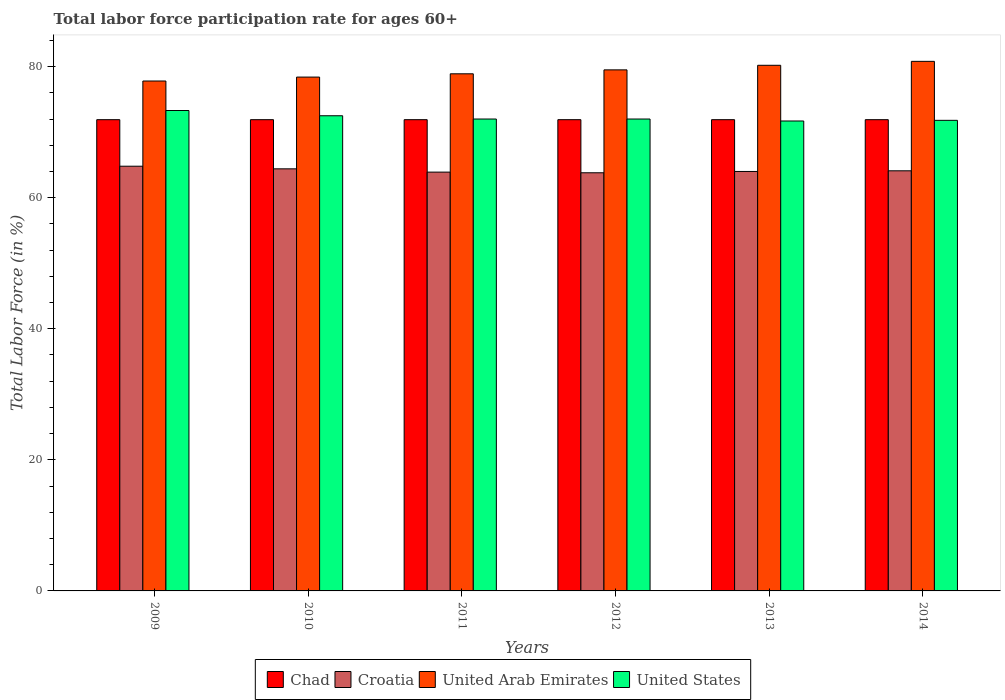How many groups of bars are there?
Your answer should be compact. 6. What is the label of the 6th group of bars from the left?
Provide a succinct answer. 2014. In how many cases, is the number of bars for a given year not equal to the number of legend labels?
Keep it short and to the point. 0. Across all years, what is the maximum labor force participation rate in United Arab Emirates?
Your answer should be compact. 80.8. Across all years, what is the minimum labor force participation rate in United Arab Emirates?
Make the answer very short. 77.8. In which year was the labor force participation rate in United Arab Emirates minimum?
Offer a terse response. 2009. What is the total labor force participation rate in United Arab Emirates in the graph?
Make the answer very short. 475.6. What is the difference between the labor force participation rate in Croatia in 2012 and that in 2013?
Give a very brief answer. -0.2. What is the difference between the labor force participation rate in United States in 2009 and the labor force participation rate in United Arab Emirates in 2013?
Your answer should be very brief. -6.9. What is the average labor force participation rate in Chad per year?
Keep it short and to the point. 71.9. In the year 2011, what is the difference between the labor force participation rate in United Arab Emirates and labor force participation rate in United States?
Give a very brief answer. 6.9. In how many years, is the labor force participation rate in Croatia greater than 8 %?
Your response must be concise. 6. What is the ratio of the labor force participation rate in Chad in 2010 to that in 2012?
Your answer should be compact. 1. Is the difference between the labor force participation rate in United Arab Emirates in 2009 and 2014 greater than the difference between the labor force participation rate in United States in 2009 and 2014?
Ensure brevity in your answer.  No. What is the difference between the highest and the second highest labor force participation rate in United States?
Offer a terse response. 0.8. What is the difference between the highest and the lowest labor force participation rate in Croatia?
Your answer should be compact. 1. In how many years, is the labor force participation rate in United States greater than the average labor force participation rate in United States taken over all years?
Your response must be concise. 2. Is the sum of the labor force participation rate in Chad in 2010 and 2011 greater than the maximum labor force participation rate in United States across all years?
Keep it short and to the point. Yes. Is it the case that in every year, the sum of the labor force participation rate in Chad and labor force participation rate in United States is greater than the sum of labor force participation rate in United Arab Emirates and labor force participation rate in Croatia?
Provide a short and direct response. No. What does the 4th bar from the left in 2014 represents?
Your response must be concise. United States. What does the 3rd bar from the right in 2014 represents?
Offer a terse response. Croatia. How many bars are there?
Your response must be concise. 24. Are all the bars in the graph horizontal?
Provide a succinct answer. No. How many years are there in the graph?
Provide a short and direct response. 6. What is the difference between two consecutive major ticks on the Y-axis?
Give a very brief answer. 20. Does the graph contain grids?
Your answer should be compact. No. How are the legend labels stacked?
Offer a very short reply. Horizontal. What is the title of the graph?
Keep it short and to the point. Total labor force participation rate for ages 60+. Does "Papua New Guinea" appear as one of the legend labels in the graph?
Offer a very short reply. No. What is the Total Labor Force (in %) of Chad in 2009?
Make the answer very short. 71.9. What is the Total Labor Force (in %) in Croatia in 2009?
Provide a short and direct response. 64.8. What is the Total Labor Force (in %) of United Arab Emirates in 2009?
Keep it short and to the point. 77.8. What is the Total Labor Force (in %) of United States in 2009?
Your answer should be compact. 73.3. What is the Total Labor Force (in %) of Chad in 2010?
Give a very brief answer. 71.9. What is the Total Labor Force (in %) in Croatia in 2010?
Offer a very short reply. 64.4. What is the Total Labor Force (in %) of United Arab Emirates in 2010?
Your response must be concise. 78.4. What is the Total Labor Force (in %) in United States in 2010?
Your answer should be compact. 72.5. What is the Total Labor Force (in %) of Chad in 2011?
Provide a succinct answer. 71.9. What is the Total Labor Force (in %) of Croatia in 2011?
Your response must be concise. 63.9. What is the Total Labor Force (in %) of United Arab Emirates in 2011?
Ensure brevity in your answer.  78.9. What is the Total Labor Force (in %) of Chad in 2012?
Ensure brevity in your answer.  71.9. What is the Total Labor Force (in %) in Croatia in 2012?
Keep it short and to the point. 63.8. What is the Total Labor Force (in %) in United Arab Emirates in 2012?
Your answer should be very brief. 79.5. What is the Total Labor Force (in %) in United States in 2012?
Offer a terse response. 72. What is the Total Labor Force (in %) in Chad in 2013?
Your answer should be very brief. 71.9. What is the Total Labor Force (in %) of United Arab Emirates in 2013?
Offer a very short reply. 80.2. What is the Total Labor Force (in %) in United States in 2013?
Offer a very short reply. 71.7. What is the Total Labor Force (in %) of Chad in 2014?
Your answer should be compact. 71.9. What is the Total Labor Force (in %) of Croatia in 2014?
Ensure brevity in your answer.  64.1. What is the Total Labor Force (in %) in United Arab Emirates in 2014?
Make the answer very short. 80.8. What is the Total Labor Force (in %) in United States in 2014?
Make the answer very short. 71.8. Across all years, what is the maximum Total Labor Force (in %) of Chad?
Your answer should be very brief. 71.9. Across all years, what is the maximum Total Labor Force (in %) in Croatia?
Offer a very short reply. 64.8. Across all years, what is the maximum Total Labor Force (in %) of United Arab Emirates?
Your response must be concise. 80.8. Across all years, what is the maximum Total Labor Force (in %) in United States?
Make the answer very short. 73.3. Across all years, what is the minimum Total Labor Force (in %) in Chad?
Your answer should be compact. 71.9. Across all years, what is the minimum Total Labor Force (in %) of Croatia?
Provide a succinct answer. 63.8. Across all years, what is the minimum Total Labor Force (in %) in United Arab Emirates?
Ensure brevity in your answer.  77.8. Across all years, what is the minimum Total Labor Force (in %) in United States?
Provide a short and direct response. 71.7. What is the total Total Labor Force (in %) in Chad in the graph?
Make the answer very short. 431.4. What is the total Total Labor Force (in %) in Croatia in the graph?
Ensure brevity in your answer.  385. What is the total Total Labor Force (in %) of United Arab Emirates in the graph?
Make the answer very short. 475.6. What is the total Total Labor Force (in %) in United States in the graph?
Provide a succinct answer. 433.3. What is the difference between the Total Labor Force (in %) of Croatia in 2009 and that in 2011?
Offer a terse response. 0.9. What is the difference between the Total Labor Force (in %) in United States in 2009 and that in 2011?
Make the answer very short. 1.3. What is the difference between the Total Labor Force (in %) in Chad in 2009 and that in 2012?
Keep it short and to the point. 0. What is the difference between the Total Labor Force (in %) of United States in 2009 and that in 2012?
Make the answer very short. 1.3. What is the difference between the Total Labor Force (in %) in Chad in 2009 and that in 2013?
Your answer should be compact. 0. What is the difference between the Total Labor Force (in %) of United States in 2009 and that in 2013?
Keep it short and to the point. 1.6. What is the difference between the Total Labor Force (in %) in Chad in 2009 and that in 2014?
Offer a very short reply. 0. What is the difference between the Total Labor Force (in %) in Croatia in 2009 and that in 2014?
Keep it short and to the point. 0.7. What is the difference between the Total Labor Force (in %) in United Arab Emirates in 2009 and that in 2014?
Ensure brevity in your answer.  -3. What is the difference between the Total Labor Force (in %) in United States in 2009 and that in 2014?
Offer a terse response. 1.5. What is the difference between the Total Labor Force (in %) in Chad in 2010 and that in 2011?
Offer a very short reply. 0. What is the difference between the Total Labor Force (in %) in Croatia in 2010 and that in 2011?
Your answer should be very brief. 0.5. What is the difference between the Total Labor Force (in %) of Chad in 2010 and that in 2012?
Your response must be concise. 0. What is the difference between the Total Labor Force (in %) of Croatia in 2010 and that in 2012?
Ensure brevity in your answer.  0.6. What is the difference between the Total Labor Force (in %) in United States in 2010 and that in 2012?
Your response must be concise. 0.5. What is the difference between the Total Labor Force (in %) in United States in 2010 and that in 2013?
Provide a succinct answer. 0.8. What is the difference between the Total Labor Force (in %) of Croatia in 2010 and that in 2014?
Your answer should be compact. 0.3. What is the difference between the Total Labor Force (in %) of United Arab Emirates in 2010 and that in 2014?
Make the answer very short. -2.4. What is the difference between the Total Labor Force (in %) in United States in 2010 and that in 2014?
Offer a terse response. 0.7. What is the difference between the Total Labor Force (in %) in Chad in 2011 and that in 2012?
Your answer should be compact. 0. What is the difference between the Total Labor Force (in %) in Croatia in 2011 and that in 2012?
Offer a very short reply. 0.1. What is the difference between the Total Labor Force (in %) of United States in 2011 and that in 2012?
Offer a terse response. 0. What is the difference between the Total Labor Force (in %) in Chad in 2011 and that in 2013?
Your answer should be compact. 0. What is the difference between the Total Labor Force (in %) of Chad in 2011 and that in 2014?
Offer a terse response. 0. What is the difference between the Total Labor Force (in %) of Chad in 2012 and that in 2013?
Provide a short and direct response. 0. What is the difference between the Total Labor Force (in %) of Croatia in 2012 and that in 2013?
Provide a short and direct response. -0.2. What is the difference between the Total Labor Force (in %) in Croatia in 2012 and that in 2014?
Ensure brevity in your answer.  -0.3. What is the difference between the Total Labor Force (in %) of United States in 2012 and that in 2014?
Your response must be concise. 0.2. What is the difference between the Total Labor Force (in %) in United Arab Emirates in 2013 and that in 2014?
Provide a succinct answer. -0.6. What is the difference between the Total Labor Force (in %) in Chad in 2009 and the Total Labor Force (in %) in Croatia in 2010?
Offer a terse response. 7.5. What is the difference between the Total Labor Force (in %) of Croatia in 2009 and the Total Labor Force (in %) of United Arab Emirates in 2010?
Ensure brevity in your answer.  -13.6. What is the difference between the Total Labor Force (in %) of Croatia in 2009 and the Total Labor Force (in %) of United States in 2010?
Your answer should be very brief. -7.7. What is the difference between the Total Labor Force (in %) of Croatia in 2009 and the Total Labor Force (in %) of United Arab Emirates in 2011?
Offer a very short reply. -14.1. What is the difference between the Total Labor Force (in %) of Croatia in 2009 and the Total Labor Force (in %) of United Arab Emirates in 2012?
Give a very brief answer. -14.7. What is the difference between the Total Labor Force (in %) of United Arab Emirates in 2009 and the Total Labor Force (in %) of United States in 2012?
Provide a succinct answer. 5.8. What is the difference between the Total Labor Force (in %) in Chad in 2009 and the Total Labor Force (in %) in Croatia in 2013?
Keep it short and to the point. 7.9. What is the difference between the Total Labor Force (in %) of Chad in 2009 and the Total Labor Force (in %) of United Arab Emirates in 2013?
Provide a succinct answer. -8.3. What is the difference between the Total Labor Force (in %) of Croatia in 2009 and the Total Labor Force (in %) of United Arab Emirates in 2013?
Offer a very short reply. -15.4. What is the difference between the Total Labor Force (in %) of Croatia in 2009 and the Total Labor Force (in %) of United States in 2013?
Ensure brevity in your answer.  -6.9. What is the difference between the Total Labor Force (in %) of Chad in 2009 and the Total Labor Force (in %) of United States in 2014?
Provide a succinct answer. 0.1. What is the difference between the Total Labor Force (in %) of Croatia in 2009 and the Total Labor Force (in %) of United Arab Emirates in 2014?
Give a very brief answer. -16. What is the difference between the Total Labor Force (in %) of Croatia in 2009 and the Total Labor Force (in %) of United States in 2014?
Make the answer very short. -7. What is the difference between the Total Labor Force (in %) of United Arab Emirates in 2009 and the Total Labor Force (in %) of United States in 2014?
Your response must be concise. 6. What is the difference between the Total Labor Force (in %) in Croatia in 2010 and the Total Labor Force (in %) in United States in 2011?
Offer a terse response. -7.6. What is the difference between the Total Labor Force (in %) in Chad in 2010 and the Total Labor Force (in %) in United States in 2012?
Make the answer very short. -0.1. What is the difference between the Total Labor Force (in %) of Croatia in 2010 and the Total Labor Force (in %) of United Arab Emirates in 2012?
Provide a succinct answer. -15.1. What is the difference between the Total Labor Force (in %) in United Arab Emirates in 2010 and the Total Labor Force (in %) in United States in 2012?
Ensure brevity in your answer.  6.4. What is the difference between the Total Labor Force (in %) of Chad in 2010 and the Total Labor Force (in %) of Croatia in 2013?
Keep it short and to the point. 7.9. What is the difference between the Total Labor Force (in %) in Chad in 2010 and the Total Labor Force (in %) in United Arab Emirates in 2013?
Ensure brevity in your answer.  -8.3. What is the difference between the Total Labor Force (in %) of Croatia in 2010 and the Total Labor Force (in %) of United Arab Emirates in 2013?
Provide a succinct answer. -15.8. What is the difference between the Total Labor Force (in %) in Croatia in 2010 and the Total Labor Force (in %) in United States in 2013?
Make the answer very short. -7.3. What is the difference between the Total Labor Force (in %) of Chad in 2010 and the Total Labor Force (in %) of Croatia in 2014?
Provide a succinct answer. 7.8. What is the difference between the Total Labor Force (in %) of Chad in 2010 and the Total Labor Force (in %) of United States in 2014?
Make the answer very short. 0.1. What is the difference between the Total Labor Force (in %) of Croatia in 2010 and the Total Labor Force (in %) of United Arab Emirates in 2014?
Your answer should be very brief. -16.4. What is the difference between the Total Labor Force (in %) of United Arab Emirates in 2010 and the Total Labor Force (in %) of United States in 2014?
Offer a terse response. 6.6. What is the difference between the Total Labor Force (in %) in Chad in 2011 and the Total Labor Force (in %) in United Arab Emirates in 2012?
Keep it short and to the point. -7.6. What is the difference between the Total Labor Force (in %) in Croatia in 2011 and the Total Labor Force (in %) in United Arab Emirates in 2012?
Offer a terse response. -15.6. What is the difference between the Total Labor Force (in %) in Croatia in 2011 and the Total Labor Force (in %) in United States in 2012?
Your answer should be very brief. -8.1. What is the difference between the Total Labor Force (in %) in Chad in 2011 and the Total Labor Force (in %) in Croatia in 2013?
Your answer should be very brief. 7.9. What is the difference between the Total Labor Force (in %) in Croatia in 2011 and the Total Labor Force (in %) in United Arab Emirates in 2013?
Your answer should be compact. -16.3. What is the difference between the Total Labor Force (in %) in Chad in 2011 and the Total Labor Force (in %) in Croatia in 2014?
Give a very brief answer. 7.8. What is the difference between the Total Labor Force (in %) in Chad in 2011 and the Total Labor Force (in %) in United Arab Emirates in 2014?
Give a very brief answer. -8.9. What is the difference between the Total Labor Force (in %) in Croatia in 2011 and the Total Labor Force (in %) in United Arab Emirates in 2014?
Keep it short and to the point. -16.9. What is the difference between the Total Labor Force (in %) of United Arab Emirates in 2011 and the Total Labor Force (in %) of United States in 2014?
Offer a terse response. 7.1. What is the difference between the Total Labor Force (in %) in Croatia in 2012 and the Total Labor Force (in %) in United Arab Emirates in 2013?
Your answer should be compact. -16.4. What is the difference between the Total Labor Force (in %) of Croatia in 2012 and the Total Labor Force (in %) of United States in 2013?
Provide a short and direct response. -7.9. What is the difference between the Total Labor Force (in %) of United Arab Emirates in 2012 and the Total Labor Force (in %) of United States in 2013?
Provide a short and direct response. 7.8. What is the difference between the Total Labor Force (in %) of Chad in 2012 and the Total Labor Force (in %) of United States in 2014?
Give a very brief answer. 0.1. What is the difference between the Total Labor Force (in %) of Croatia in 2012 and the Total Labor Force (in %) of United Arab Emirates in 2014?
Keep it short and to the point. -17. What is the difference between the Total Labor Force (in %) in Chad in 2013 and the Total Labor Force (in %) in United States in 2014?
Give a very brief answer. 0.1. What is the difference between the Total Labor Force (in %) of Croatia in 2013 and the Total Labor Force (in %) of United Arab Emirates in 2014?
Make the answer very short. -16.8. What is the difference between the Total Labor Force (in %) of United Arab Emirates in 2013 and the Total Labor Force (in %) of United States in 2014?
Give a very brief answer. 8.4. What is the average Total Labor Force (in %) in Chad per year?
Provide a short and direct response. 71.9. What is the average Total Labor Force (in %) of Croatia per year?
Give a very brief answer. 64.17. What is the average Total Labor Force (in %) in United Arab Emirates per year?
Make the answer very short. 79.27. What is the average Total Labor Force (in %) in United States per year?
Your answer should be very brief. 72.22. In the year 2009, what is the difference between the Total Labor Force (in %) of Chad and Total Labor Force (in %) of United Arab Emirates?
Ensure brevity in your answer.  -5.9. In the year 2009, what is the difference between the Total Labor Force (in %) of Chad and Total Labor Force (in %) of United States?
Offer a terse response. -1.4. In the year 2009, what is the difference between the Total Labor Force (in %) of Croatia and Total Labor Force (in %) of United Arab Emirates?
Your answer should be compact. -13. In the year 2009, what is the difference between the Total Labor Force (in %) in United Arab Emirates and Total Labor Force (in %) in United States?
Your response must be concise. 4.5. In the year 2010, what is the difference between the Total Labor Force (in %) of Chad and Total Labor Force (in %) of Croatia?
Offer a terse response. 7.5. In the year 2010, what is the difference between the Total Labor Force (in %) in Chad and Total Labor Force (in %) in United Arab Emirates?
Your answer should be compact. -6.5. In the year 2010, what is the difference between the Total Labor Force (in %) of Chad and Total Labor Force (in %) of United States?
Ensure brevity in your answer.  -0.6. In the year 2010, what is the difference between the Total Labor Force (in %) of Croatia and Total Labor Force (in %) of United Arab Emirates?
Provide a succinct answer. -14. In the year 2010, what is the difference between the Total Labor Force (in %) of Croatia and Total Labor Force (in %) of United States?
Your answer should be compact. -8.1. In the year 2010, what is the difference between the Total Labor Force (in %) of United Arab Emirates and Total Labor Force (in %) of United States?
Make the answer very short. 5.9. In the year 2011, what is the difference between the Total Labor Force (in %) of Chad and Total Labor Force (in %) of Croatia?
Offer a very short reply. 8. In the year 2011, what is the difference between the Total Labor Force (in %) of Chad and Total Labor Force (in %) of United Arab Emirates?
Make the answer very short. -7. In the year 2012, what is the difference between the Total Labor Force (in %) in Chad and Total Labor Force (in %) in Croatia?
Offer a terse response. 8.1. In the year 2012, what is the difference between the Total Labor Force (in %) in Chad and Total Labor Force (in %) in United Arab Emirates?
Provide a succinct answer. -7.6. In the year 2012, what is the difference between the Total Labor Force (in %) in Croatia and Total Labor Force (in %) in United Arab Emirates?
Provide a short and direct response. -15.7. In the year 2012, what is the difference between the Total Labor Force (in %) of Croatia and Total Labor Force (in %) of United States?
Your answer should be compact. -8.2. In the year 2013, what is the difference between the Total Labor Force (in %) of Chad and Total Labor Force (in %) of Croatia?
Ensure brevity in your answer.  7.9. In the year 2013, what is the difference between the Total Labor Force (in %) of Chad and Total Labor Force (in %) of United States?
Give a very brief answer. 0.2. In the year 2013, what is the difference between the Total Labor Force (in %) in Croatia and Total Labor Force (in %) in United Arab Emirates?
Give a very brief answer. -16.2. In the year 2013, what is the difference between the Total Labor Force (in %) of United Arab Emirates and Total Labor Force (in %) of United States?
Keep it short and to the point. 8.5. In the year 2014, what is the difference between the Total Labor Force (in %) of Croatia and Total Labor Force (in %) of United Arab Emirates?
Provide a succinct answer. -16.7. In the year 2014, what is the difference between the Total Labor Force (in %) in United Arab Emirates and Total Labor Force (in %) in United States?
Offer a terse response. 9. What is the ratio of the Total Labor Force (in %) of Croatia in 2009 to that in 2011?
Ensure brevity in your answer.  1.01. What is the ratio of the Total Labor Force (in %) of United Arab Emirates in 2009 to that in 2011?
Provide a short and direct response. 0.99. What is the ratio of the Total Labor Force (in %) in United States in 2009 to that in 2011?
Provide a short and direct response. 1.02. What is the ratio of the Total Labor Force (in %) of Chad in 2009 to that in 2012?
Your answer should be very brief. 1. What is the ratio of the Total Labor Force (in %) of Croatia in 2009 to that in 2012?
Ensure brevity in your answer.  1.02. What is the ratio of the Total Labor Force (in %) in United Arab Emirates in 2009 to that in 2012?
Keep it short and to the point. 0.98. What is the ratio of the Total Labor Force (in %) in United States in 2009 to that in 2012?
Provide a short and direct response. 1.02. What is the ratio of the Total Labor Force (in %) of Croatia in 2009 to that in 2013?
Give a very brief answer. 1.01. What is the ratio of the Total Labor Force (in %) of United Arab Emirates in 2009 to that in 2013?
Ensure brevity in your answer.  0.97. What is the ratio of the Total Labor Force (in %) in United States in 2009 to that in 2013?
Make the answer very short. 1.02. What is the ratio of the Total Labor Force (in %) in Croatia in 2009 to that in 2014?
Offer a very short reply. 1.01. What is the ratio of the Total Labor Force (in %) of United Arab Emirates in 2009 to that in 2014?
Your answer should be very brief. 0.96. What is the ratio of the Total Labor Force (in %) in United States in 2009 to that in 2014?
Give a very brief answer. 1.02. What is the ratio of the Total Labor Force (in %) in United States in 2010 to that in 2011?
Offer a terse response. 1.01. What is the ratio of the Total Labor Force (in %) in Chad in 2010 to that in 2012?
Provide a succinct answer. 1. What is the ratio of the Total Labor Force (in %) of Croatia in 2010 to that in 2012?
Your answer should be very brief. 1.01. What is the ratio of the Total Labor Force (in %) in United Arab Emirates in 2010 to that in 2012?
Give a very brief answer. 0.99. What is the ratio of the Total Labor Force (in %) of United Arab Emirates in 2010 to that in 2013?
Your answer should be compact. 0.98. What is the ratio of the Total Labor Force (in %) in United States in 2010 to that in 2013?
Make the answer very short. 1.01. What is the ratio of the Total Labor Force (in %) of Croatia in 2010 to that in 2014?
Keep it short and to the point. 1. What is the ratio of the Total Labor Force (in %) of United Arab Emirates in 2010 to that in 2014?
Make the answer very short. 0.97. What is the ratio of the Total Labor Force (in %) in United States in 2010 to that in 2014?
Keep it short and to the point. 1.01. What is the ratio of the Total Labor Force (in %) of Chad in 2011 to that in 2012?
Your response must be concise. 1. What is the ratio of the Total Labor Force (in %) of Croatia in 2011 to that in 2012?
Provide a short and direct response. 1. What is the ratio of the Total Labor Force (in %) of United Arab Emirates in 2011 to that in 2012?
Ensure brevity in your answer.  0.99. What is the ratio of the Total Labor Force (in %) in United Arab Emirates in 2011 to that in 2013?
Provide a succinct answer. 0.98. What is the ratio of the Total Labor Force (in %) in United States in 2011 to that in 2013?
Give a very brief answer. 1. What is the ratio of the Total Labor Force (in %) of Chad in 2011 to that in 2014?
Provide a succinct answer. 1. What is the ratio of the Total Labor Force (in %) of United Arab Emirates in 2011 to that in 2014?
Your response must be concise. 0.98. What is the ratio of the Total Labor Force (in %) in United States in 2012 to that in 2013?
Provide a short and direct response. 1. What is the ratio of the Total Labor Force (in %) of Croatia in 2012 to that in 2014?
Offer a very short reply. 1. What is the ratio of the Total Labor Force (in %) of United Arab Emirates in 2012 to that in 2014?
Ensure brevity in your answer.  0.98. What is the ratio of the Total Labor Force (in %) in Chad in 2013 to that in 2014?
Offer a terse response. 1. What is the ratio of the Total Labor Force (in %) of United Arab Emirates in 2013 to that in 2014?
Give a very brief answer. 0.99. What is the ratio of the Total Labor Force (in %) of United States in 2013 to that in 2014?
Provide a short and direct response. 1. What is the difference between the highest and the second highest Total Labor Force (in %) of Croatia?
Give a very brief answer. 0.4. What is the difference between the highest and the second highest Total Labor Force (in %) in United Arab Emirates?
Keep it short and to the point. 0.6. What is the difference between the highest and the lowest Total Labor Force (in %) of Chad?
Ensure brevity in your answer.  0. What is the difference between the highest and the lowest Total Labor Force (in %) of United Arab Emirates?
Make the answer very short. 3. What is the difference between the highest and the lowest Total Labor Force (in %) of United States?
Your response must be concise. 1.6. 